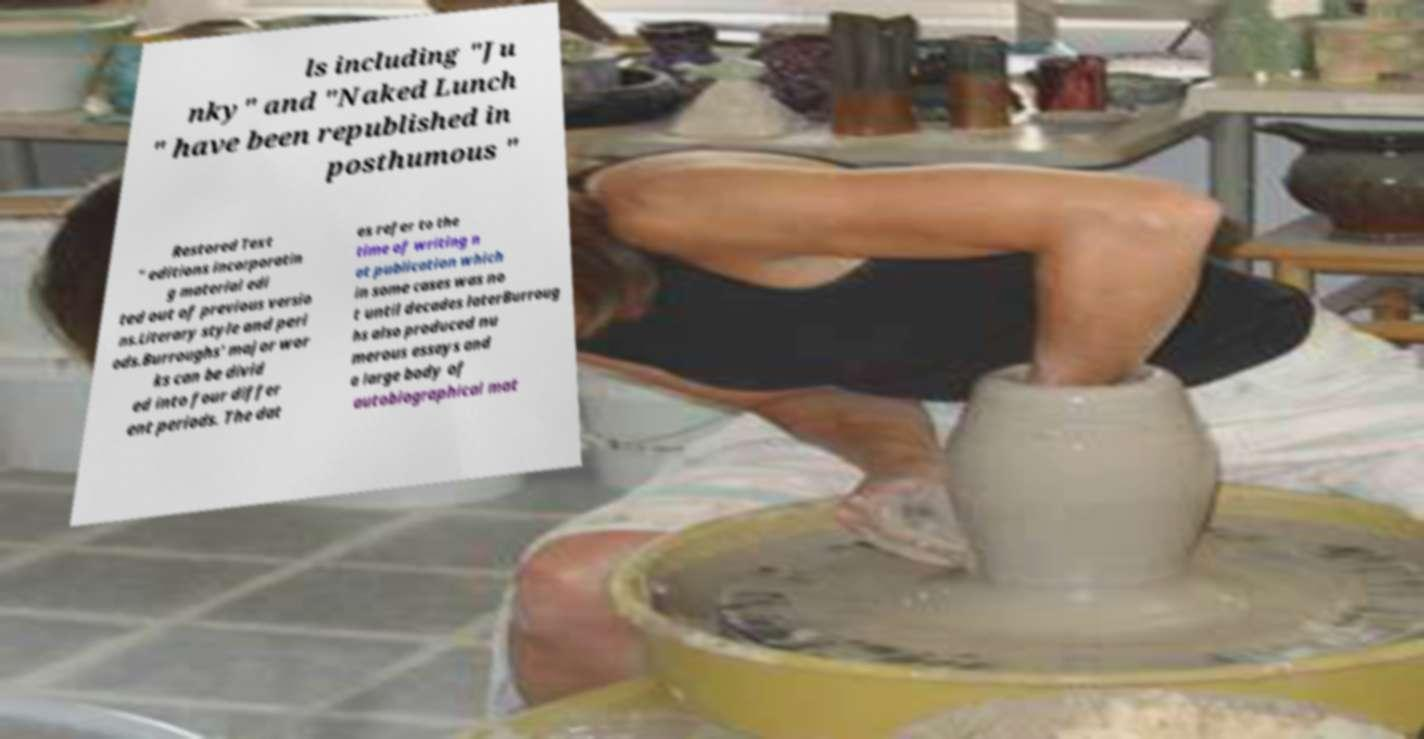There's text embedded in this image that I need extracted. Can you transcribe it verbatim? ls including "Ju nky" and "Naked Lunch " have been republished in posthumous " Restored Text " editions incorporatin g material edi ted out of previous versio ns.Literary style and peri ods.Burroughs' major wor ks can be divid ed into four differ ent periods. The dat es refer to the time of writing n ot publication which in some cases was no t until decades laterBurroug hs also produced nu merous essays and a large body of autobiographical mat 